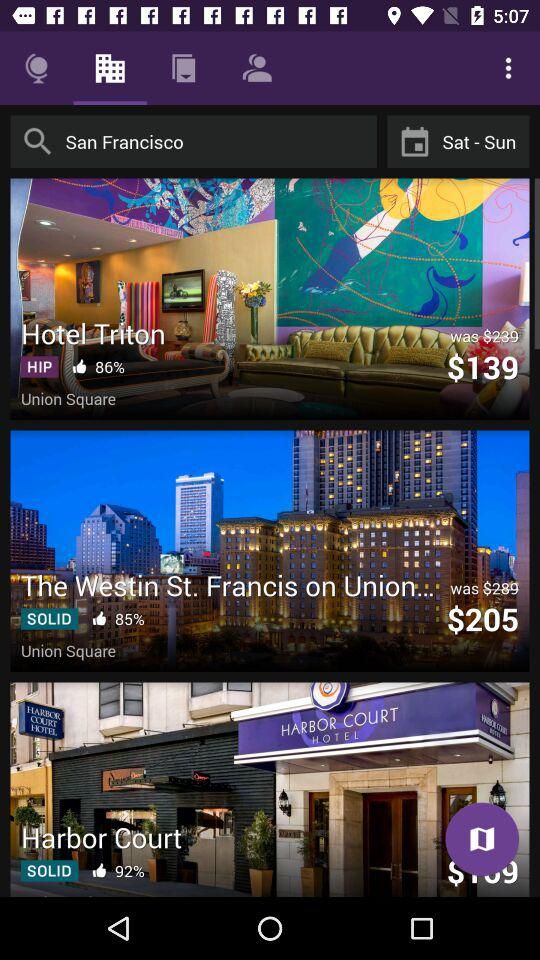What is the percentage of likes for Harbor Court? The percentage of likes is 92. 